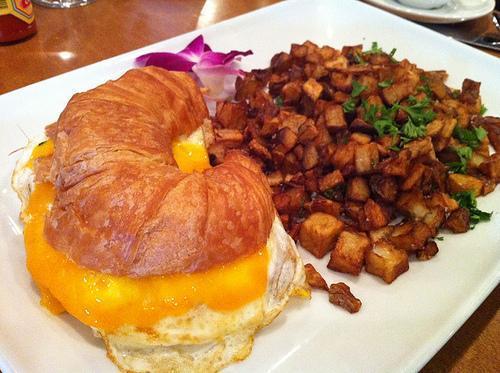How many plates of food are shown?
Give a very brief answer. 1. 